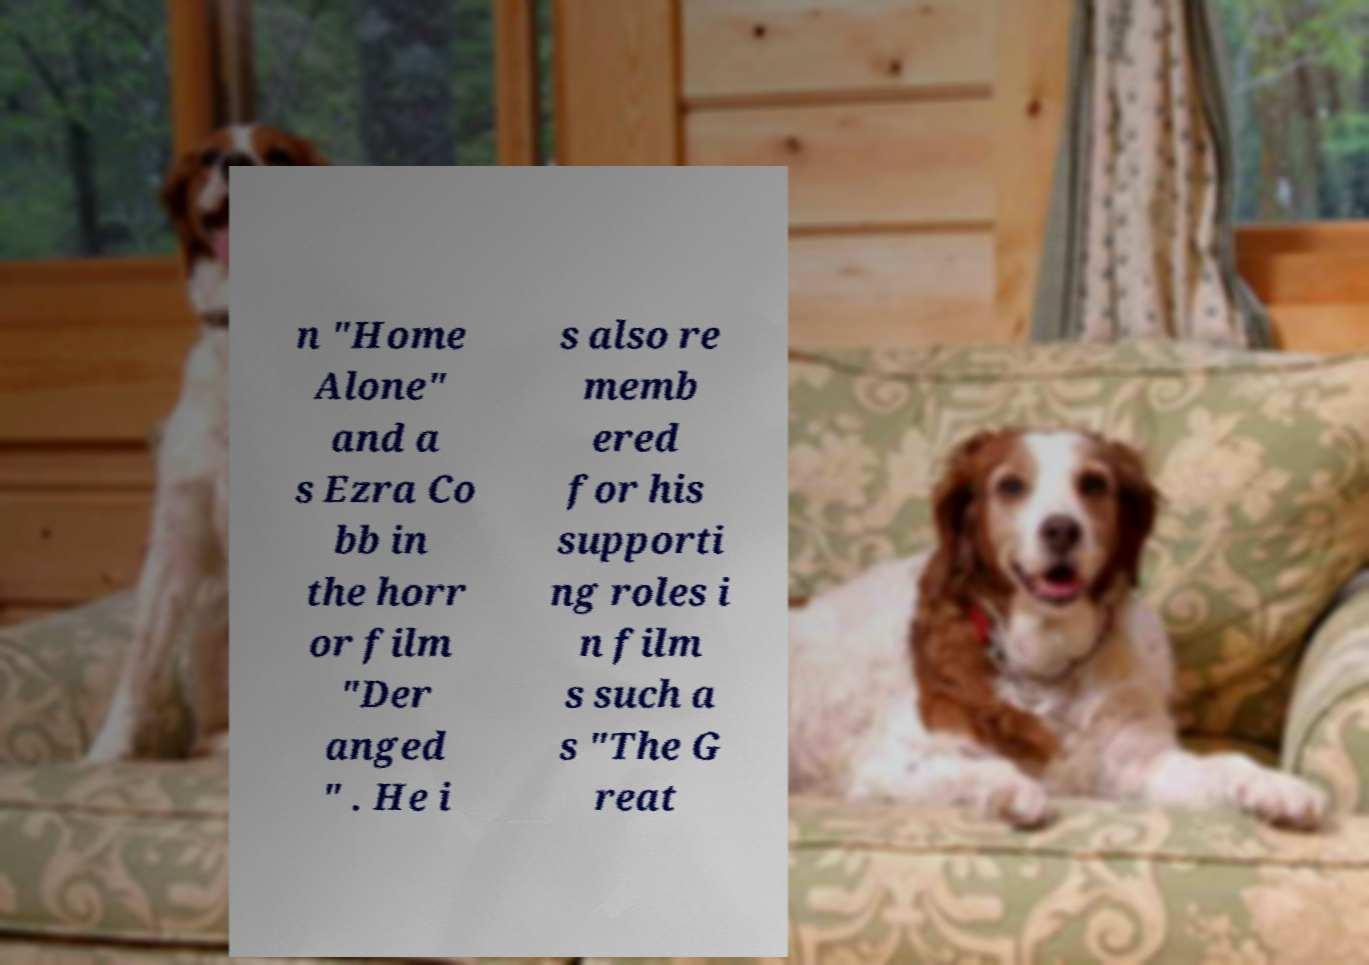Can you read and provide the text displayed in the image?This photo seems to have some interesting text. Can you extract and type it out for me? n "Home Alone" and a s Ezra Co bb in the horr or film "Der anged " . He i s also re memb ered for his supporti ng roles i n film s such a s "The G reat 